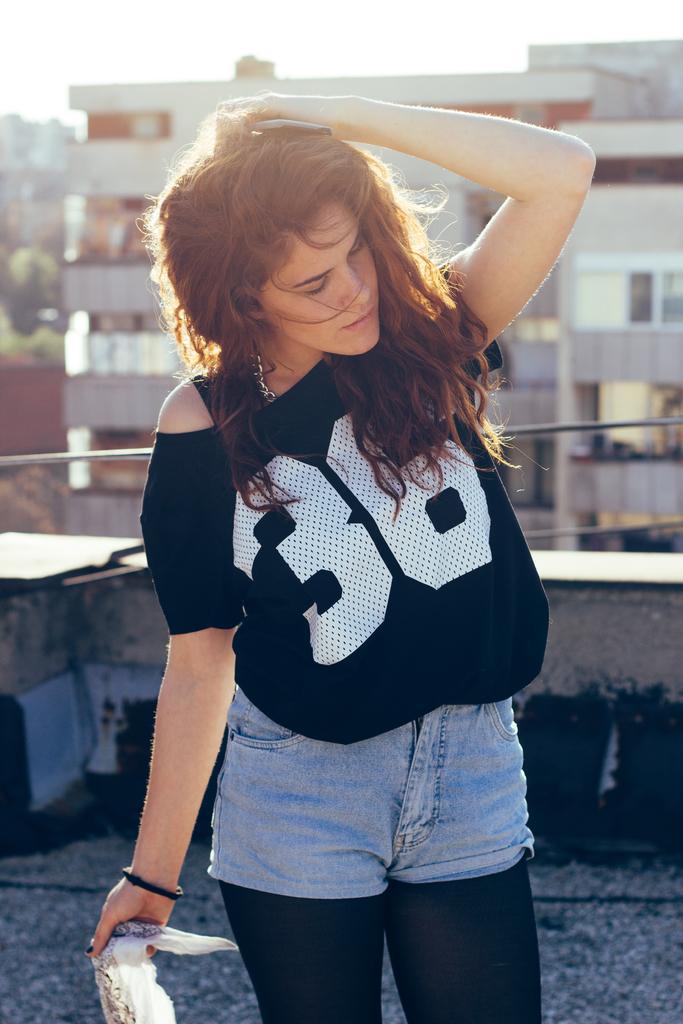Can you describe this image briefly? In this image, at the middle there is a girl standing, at the background there are some buildings and at the top there is a sky. 